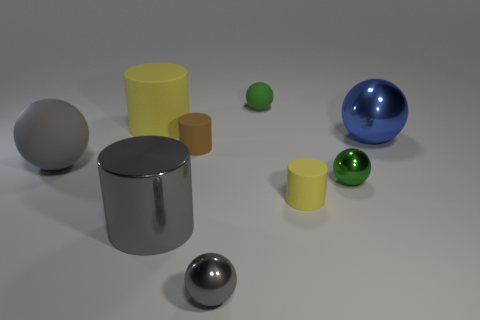There is a tiny green object that is in front of the large shiny ball; is its shape the same as the large metal object to the left of the big blue metallic ball?
Offer a terse response. No. There is a large gray matte object that is left of the large sphere to the right of the gray sphere that is behind the small gray ball; what shape is it?
Offer a terse response. Sphere. Are there more matte cylinders that are to the right of the big yellow thing than small green matte spheres?
Give a very brief answer. Yes. Are there any other big rubber objects of the same shape as the brown rubber thing?
Ensure brevity in your answer.  Yes. Is the material of the tiny gray ball the same as the tiny green sphere that is in front of the gray matte ball?
Your answer should be compact. Yes. The large shiny cylinder is what color?
Your answer should be compact. Gray. How many small yellow matte cylinders are on the right side of the large blue object that is behind the gray thing that is behind the green metallic sphere?
Make the answer very short. 0. There is a big blue metallic thing; are there any large gray things on the left side of it?
Offer a very short reply. Yes. How many large red objects have the same material as the blue thing?
Your answer should be very brief. 0. How many things are either yellow things or metal cylinders?
Offer a terse response. 3. 